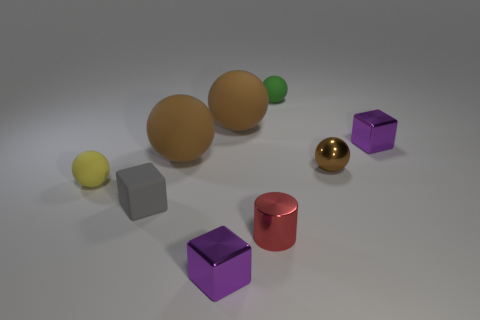Subtract all brown balls. How many were subtracted if there are1brown balls left? 2 Subtract all brown blocks. How many brown spheres are left? 3 Subtract all green spheres. How many spheres are left? 4 Subtract all brown metallic balls. How many balls are left? 4 Add 1 green spheres. How many objects exist? 10 Subtract all gray balls. Subtract all purple cylinders. How many balls are left? 5 Subtract all cylinders. How many objects are left? 8 Add 6 brown matte spheres. How many brown matte spheres are left? 8 Add 8 green objects. How many green objects exist? 9 Subtract 0 brown cubes. How many objects are left? 9 